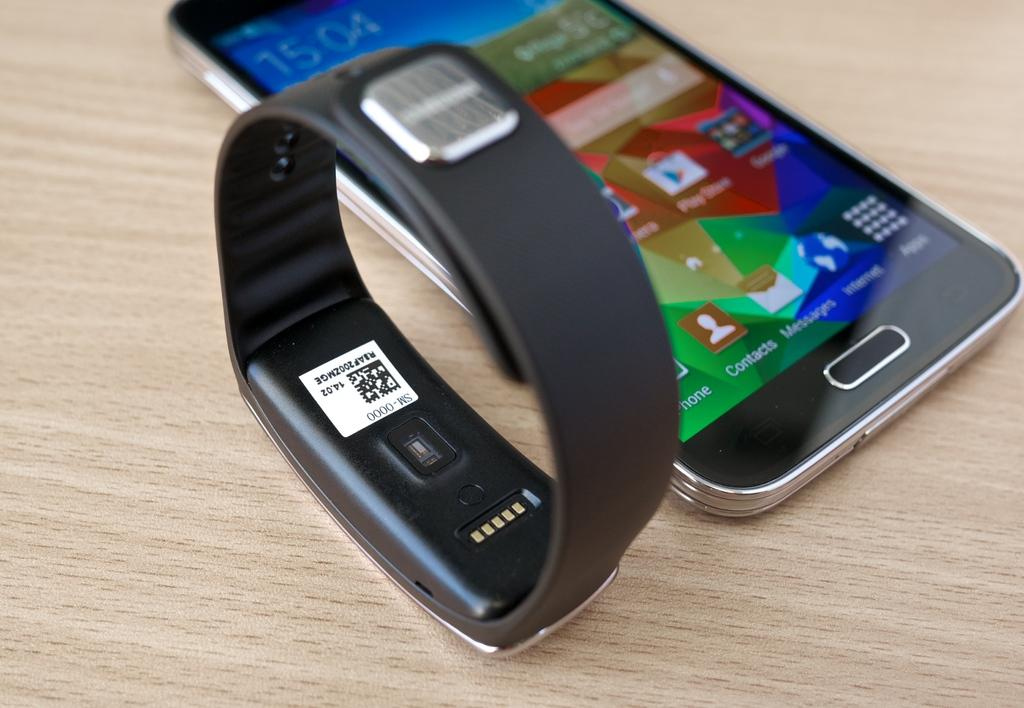<image>
Write a terse but informative summary of the picture. wooden surface with a cellphone showing time at 15:04 and fitbit with label on back with SM-0000 on it 